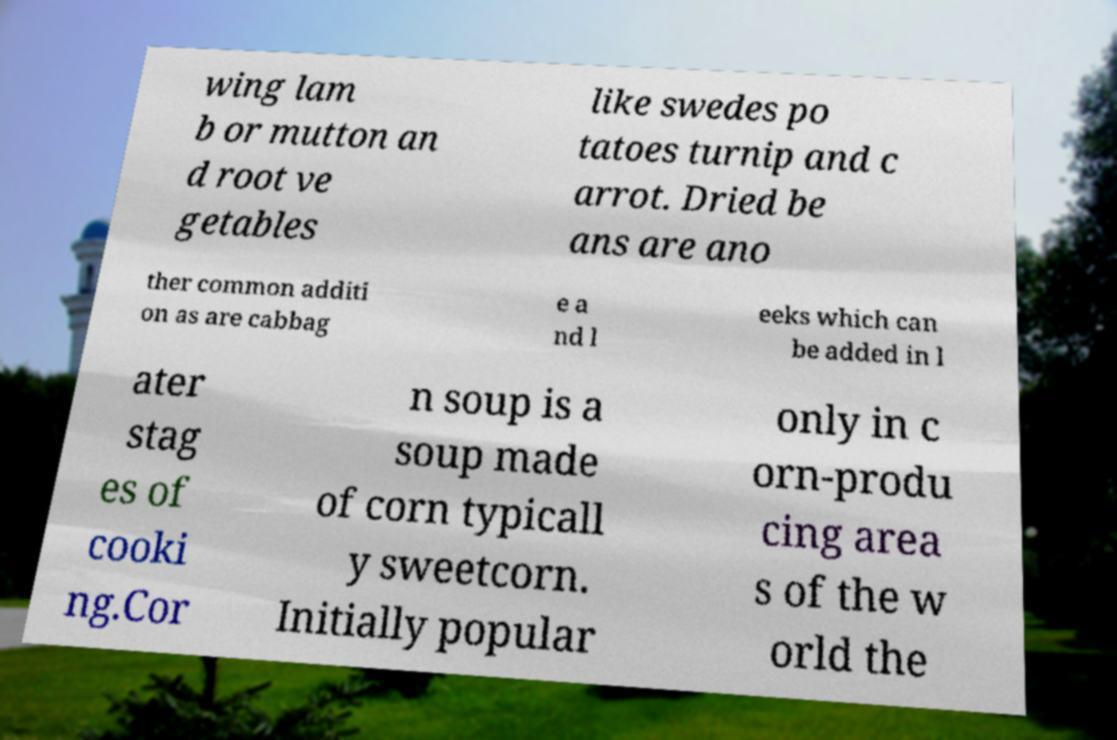Can you read and provide the text displayed in the image?This photo seems to have some interesting text. Can you extract and type it out for me? wing lam b or mutton an d root ve getables like swedes po tatoes turnip and c arrot. Dried be ans are ano ther common additi on as are cabbag e a nd l eeks which can be added in l ater stag es of cooki ng.Cor n soup is a soup made of corn typicall y sweetcorn. Initially popular only in c orn-produ cing area s of the w orld the 